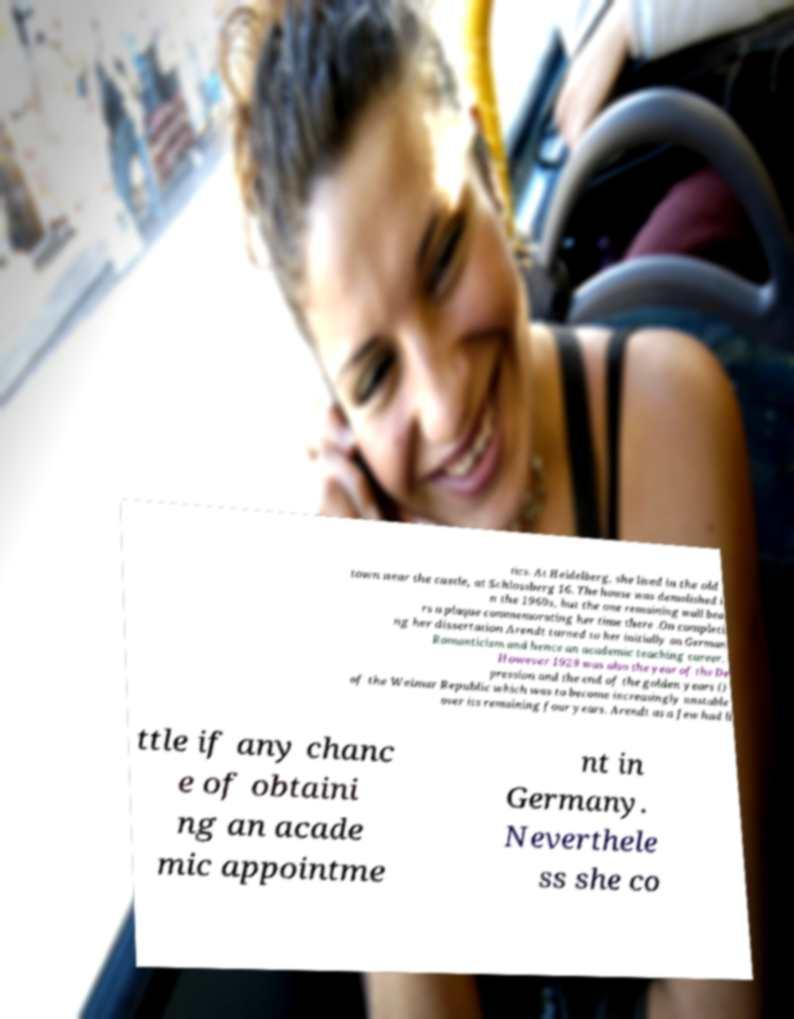Please identify and transcribe the text found in this image. tics. At Heidelberg, she lived in the old town near the castle, at Schlossberg 16. The house was demolished i n the 1960s, but the one remaining wall bea rs a plaque commemorating her time there .On completi ng her dissertation Arendt turned to her initially on German Romanticism and hence an academic teaching career. However 1929 was also the year of the De pression and the end of the golden years () of the Weimar Republic which was to become increasingly unstable over its remaining four years. Arendt as a Jew had li ttle if any chanc e of obtaini ng an acade mic appointme nt in Germany. Neverthele ss she co 